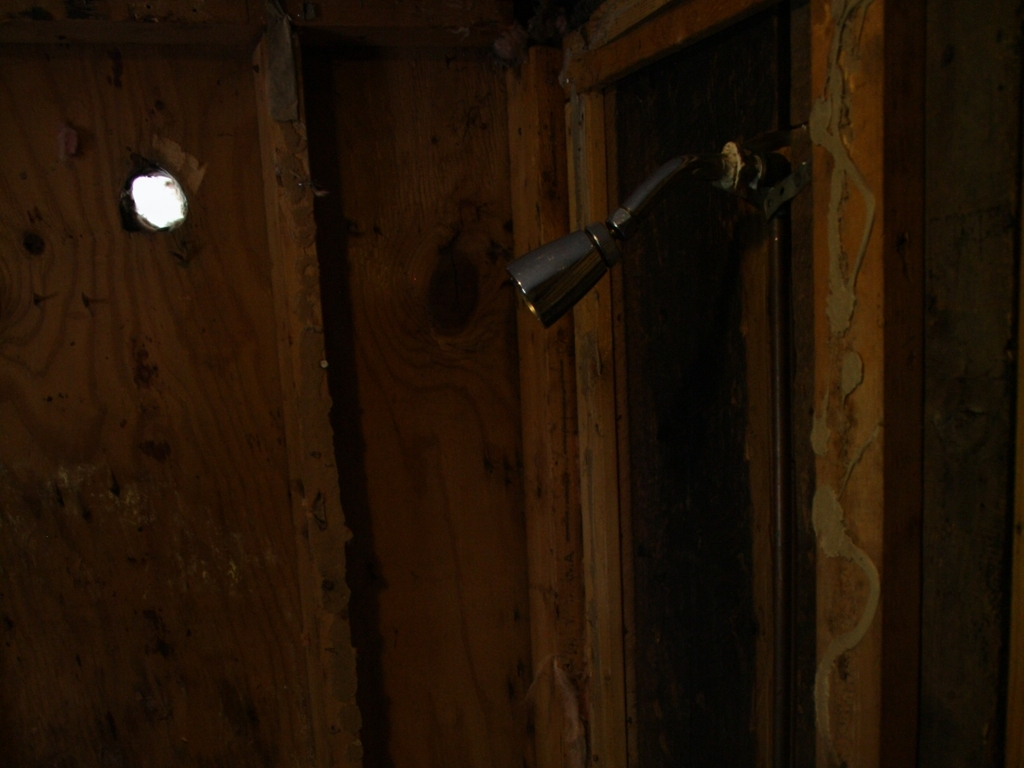What do you think this space was used for? Given the presence of the faucet without an accompanying sink and the general state of neglect, this space might have been a utility room or a part of a house under renovation. The hole in the wall and the exposed insulation suggest unfinished construction or demolition. 